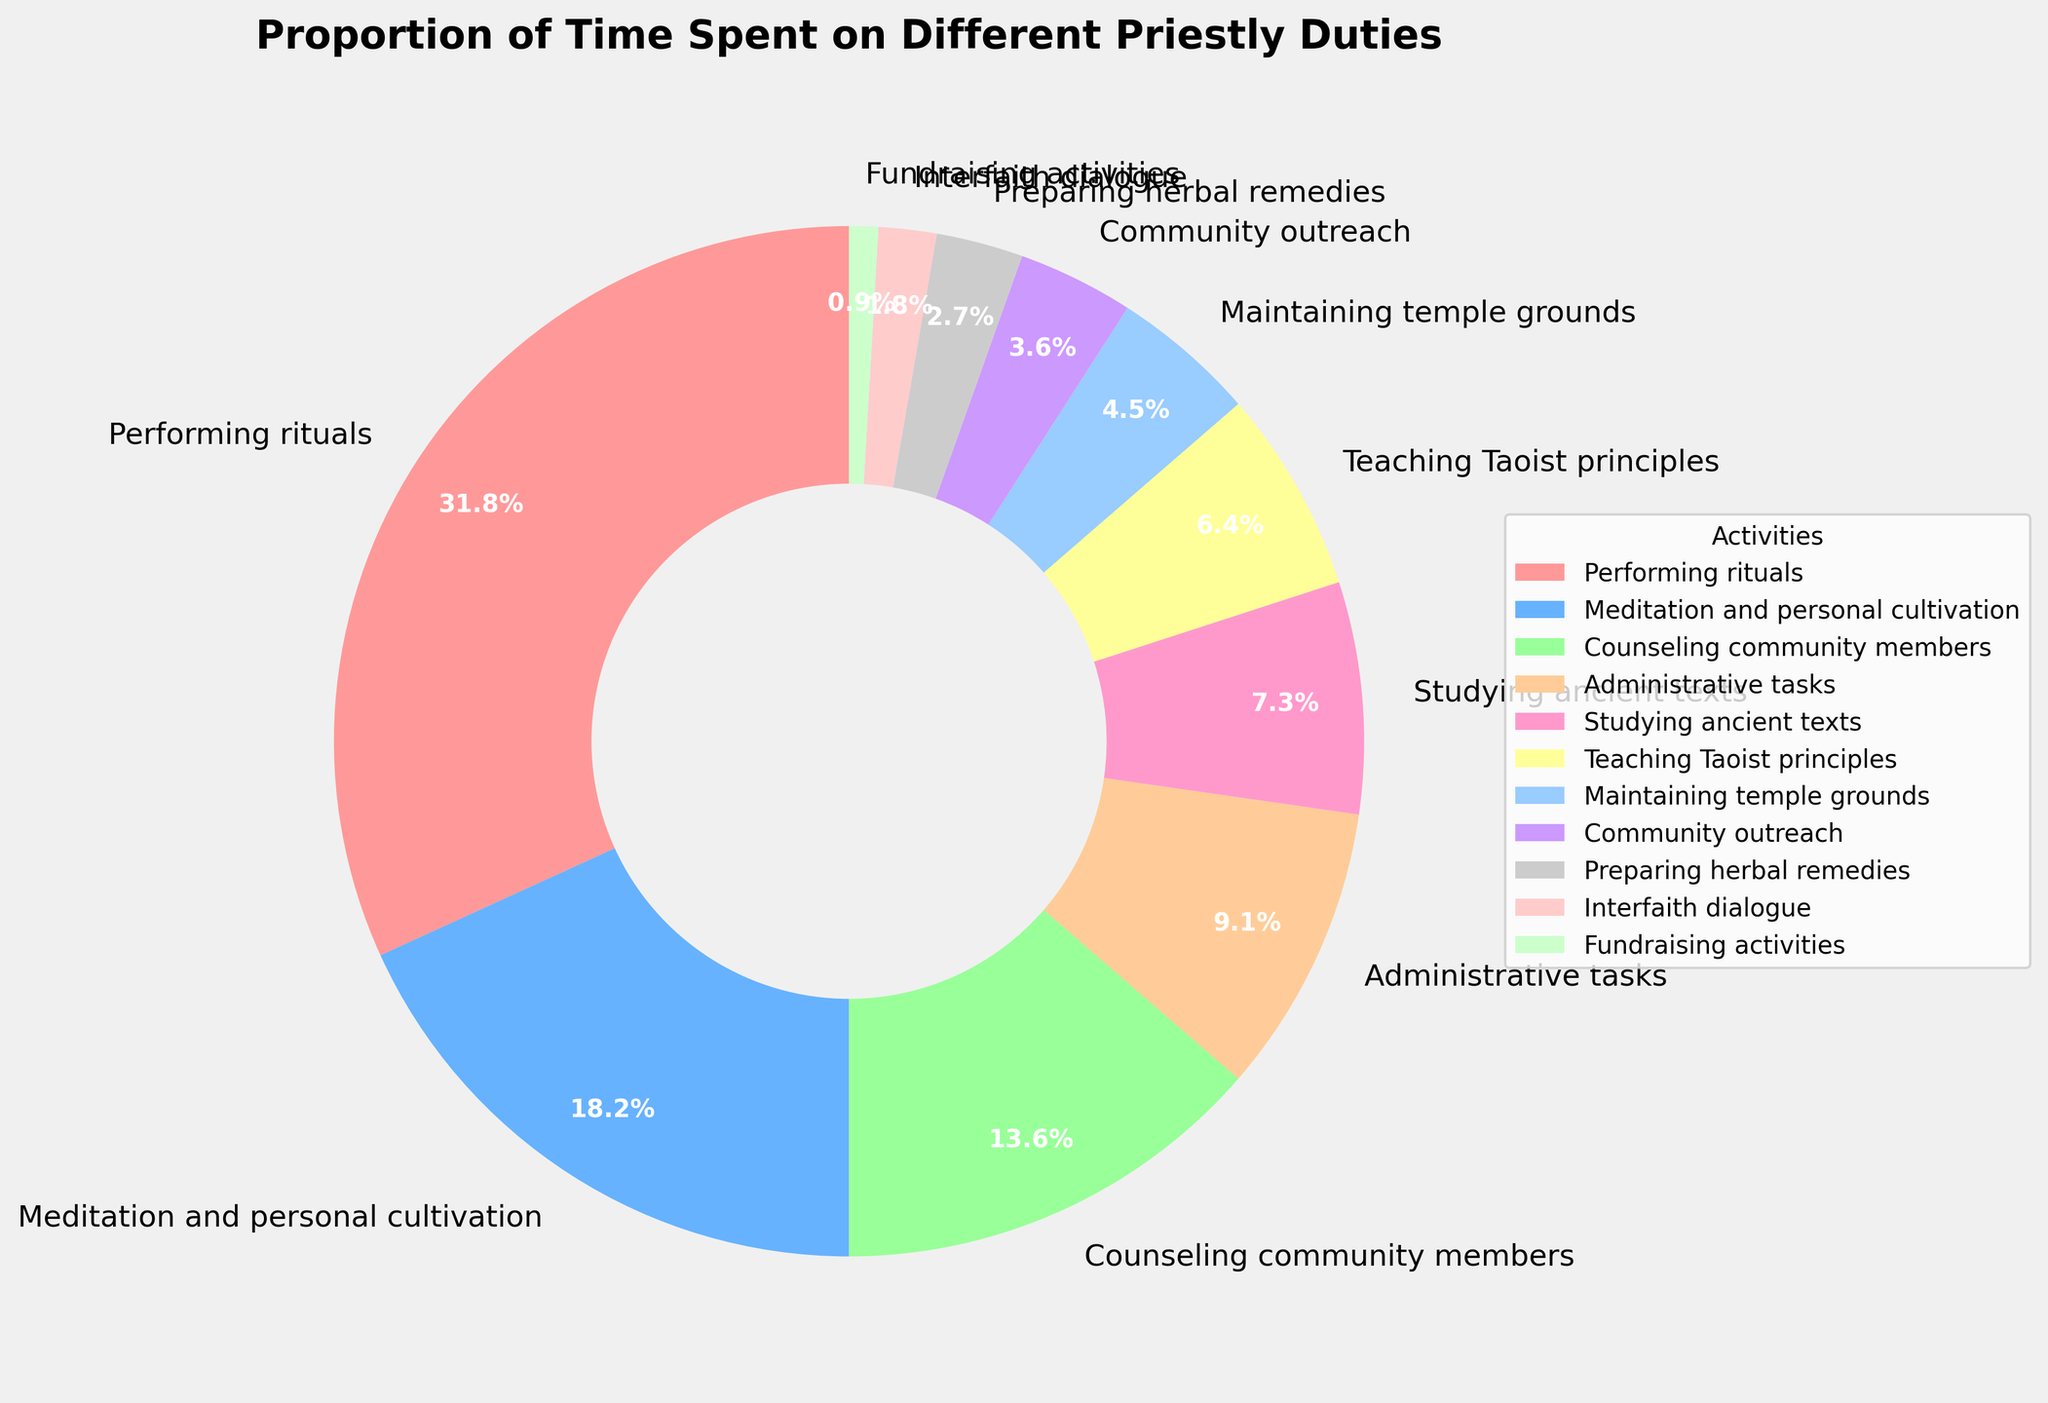What activity takes up the largest percentage of time? By looking at the pie chart, the segment labeled "Performing rituals" occupies the largest area. The label shows that Performing rituals takes up 35% of the time, which is larger than any other segment.
Answer: Performing rituals Which activity takes up the smallest percentage of time? In the pie chart, the segment labeled "Fundraising activities" is the smallest, occupying only 1% of the time. This is smaller than all other segments.
Answer: Fundraising activities How much more time is spent on Performing rituals compared to Studying ancient texts? "Performing rituals" takes up 35% of the time, and "Studying ancient texts" takes up 8%. The difference is calculated as 35% - 8% = 27%.
Answer: 27% What is the total percentage of time spent on Meditation and personal cultivation and Preparing herbal remedies combined? "Meditation and personal cultivation" takes up 20% of the time, and "Preparing herbal remedies" takes up 3%. Adding these together gives 20% + 3% = 23%.
Answer: 23% Are the combined percentages for Teaching Taoist principles and Community outreach greater than the time spent on Counseling community members? "Teaching Taoist principles" is 7%, and "Community outreach" is 4%. Together, they add up to 7% + 4% = 11%, which is less than the 15% spent on "Counseling community members".
Answer: No What percentage of time is spent on non-ritual activities? The time spent on "Performing rituals" is 35%. To find the time spent on non-ritual activities, subtract this from 100%: 100% - 35% = 65%.
Answer: 65% Which activity's segment is visually represented with the smallest area directly adjacent to it? The "Interfaith dialogue" segment, which occupies 2%, is visually the smallest already and is right next to the "Fundraising activities" segment with 1%. These are the two smallest segments.
Answer: Fundraising activities Are administrative tasks and maintaining temple grounds collectively greater than Performing rituals? "Administrative tasks" take up 10% and "Maintaining temple grounds" takes up 5%, adding to a total of 10% + 5% = 15%, which is less than the 35% spent on "Performing rituals".
Answer: No 